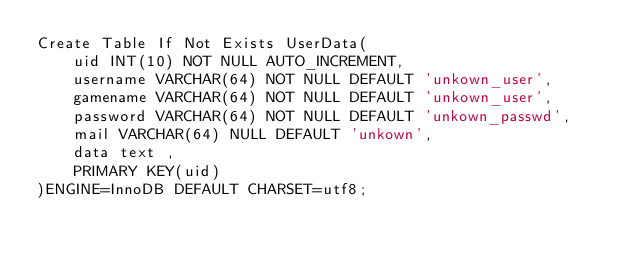Convert code to text. <code><loc_0><loc_0><loc_500><loc_500><_SQL_>Create Table If Not Exists UserData(
    uid INT(10) NOT NULL AUTO_INCREMENT,
    username VARCHAR(64) NOT NULL DEFAULT 'unkown_user',
    gamename VARCHAR(64) NOT NULL DEFAULT 'unkown_user',
    password VARCHAR(64) NOT NULL DEFAULT 'unkown_passwd',
    mail VARCHAR(64) NULL DEFAULT 'unkown',
    data text ,
    PRIMARY KEY(uid)
)ENGINE=InnoDB DEFAULT CHARSET=utf8;</code> 